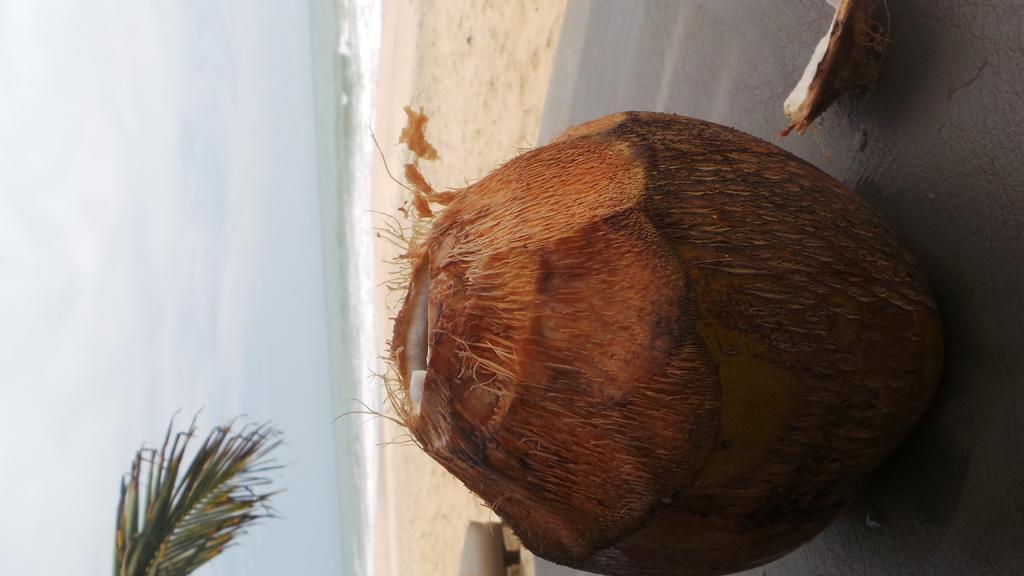In one or two sentences, can you explain what this image depicts? Here we can see a coconut. In the background we can see water and sky. 